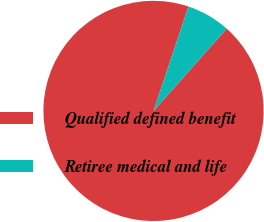<chart> <loc_0><loc_0><loc_500><loc_500><pie_chart><fcel>Qualified defined benefit<fcel>Retiree medical and life<nl><fcel>93.57%<fcel>6.43%<nl></chart> 